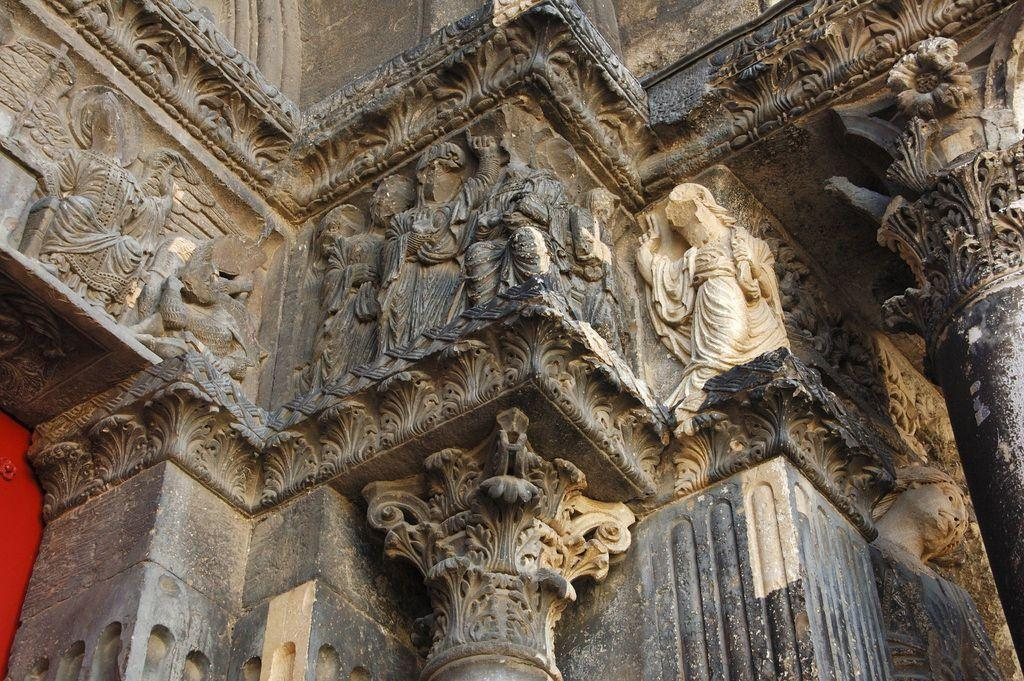What type of decorations can be seen on the pillars in the image? There are carved sculptures on the pillars in the image. What type of decorations can be seen on the walls in the image? There are carved sculptures on the walls in the image. How many boys are playing in the rainstorm depicted on the walls in the image? There is no depiction of boys playing in a rainstorm in the image; it features carved sculptures on the walls and pillars. 